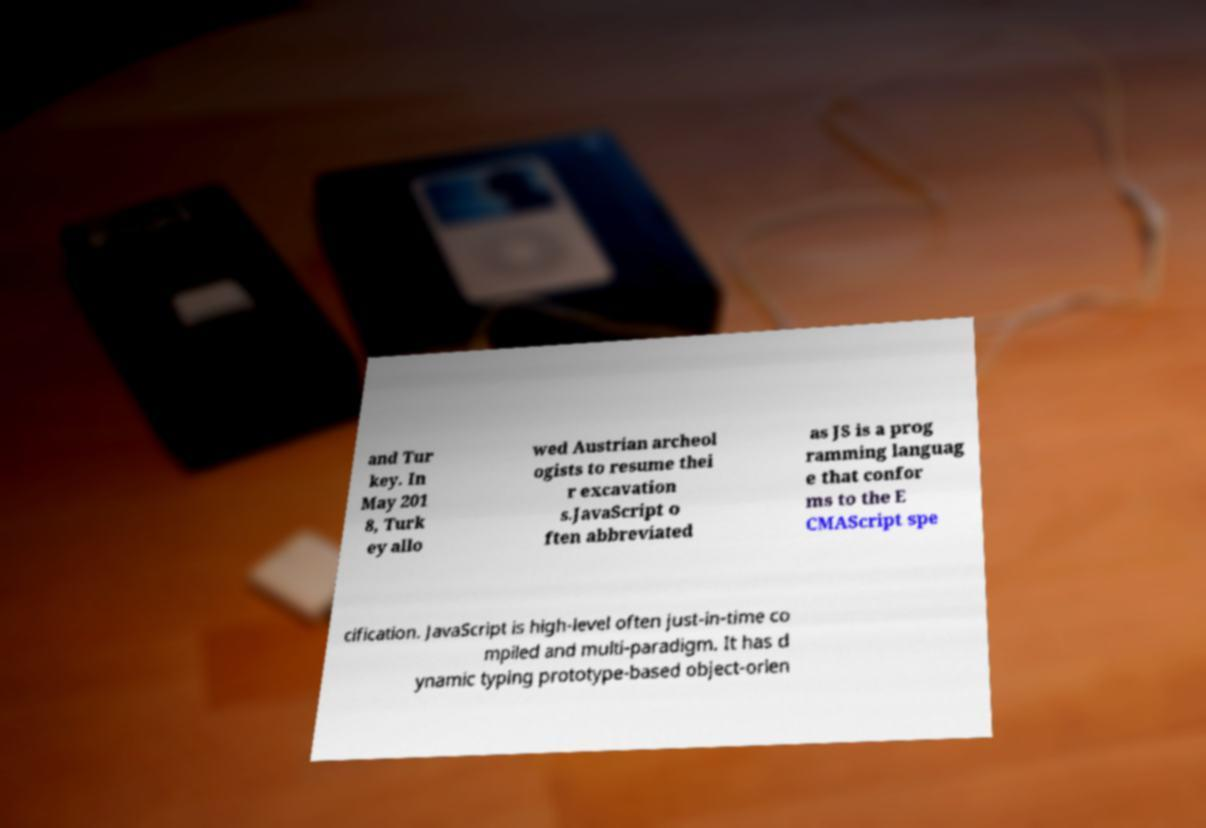There's text embedded in this image that I need extracted. Can you transcribe it verbatim? and Tur key. In May 201 8, Turk ey allo wed Austrian archeol ogists to resume thei r excavation s.JavaScript o ften abbreviated as JS is a prog ramming languag e that confor ms to the E CMAScript spe cification. JavaScript is high-level often just-in-time co mpiled and multi-paradigm. It has d ynamic typing prototype-based object-orien 